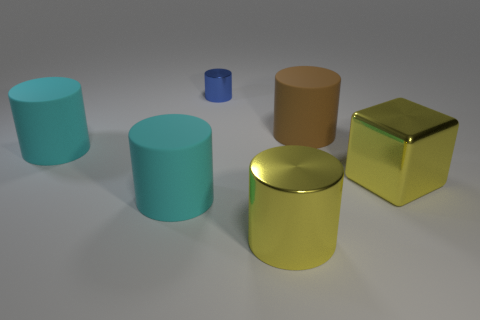Subtract 2 cylinders. How many cylinders are left? 3 Subtract all big yellow metallic cylinders. How many cylinders are left? 4 Subtract all brown cylinders. How many cylinders are left? 4 Subtract all brown cylinders. Subtract all brown cubes. How many cylinders are left? 4 Add 1 big rubber objects. How many objects exist? 7 Subtract all cylinders. How many objects are left? 1 Add 4 cylinders. How many cylinders exist? 9 Subtract 1 yellow cylinders. How many objects are left? 5 Subtract all blue metal cylinders. Subtract all yellow shiny things. How many objects are left? 3 Add 4 yellow metallic blocks. How many yellow metallic blocks are left? 5 